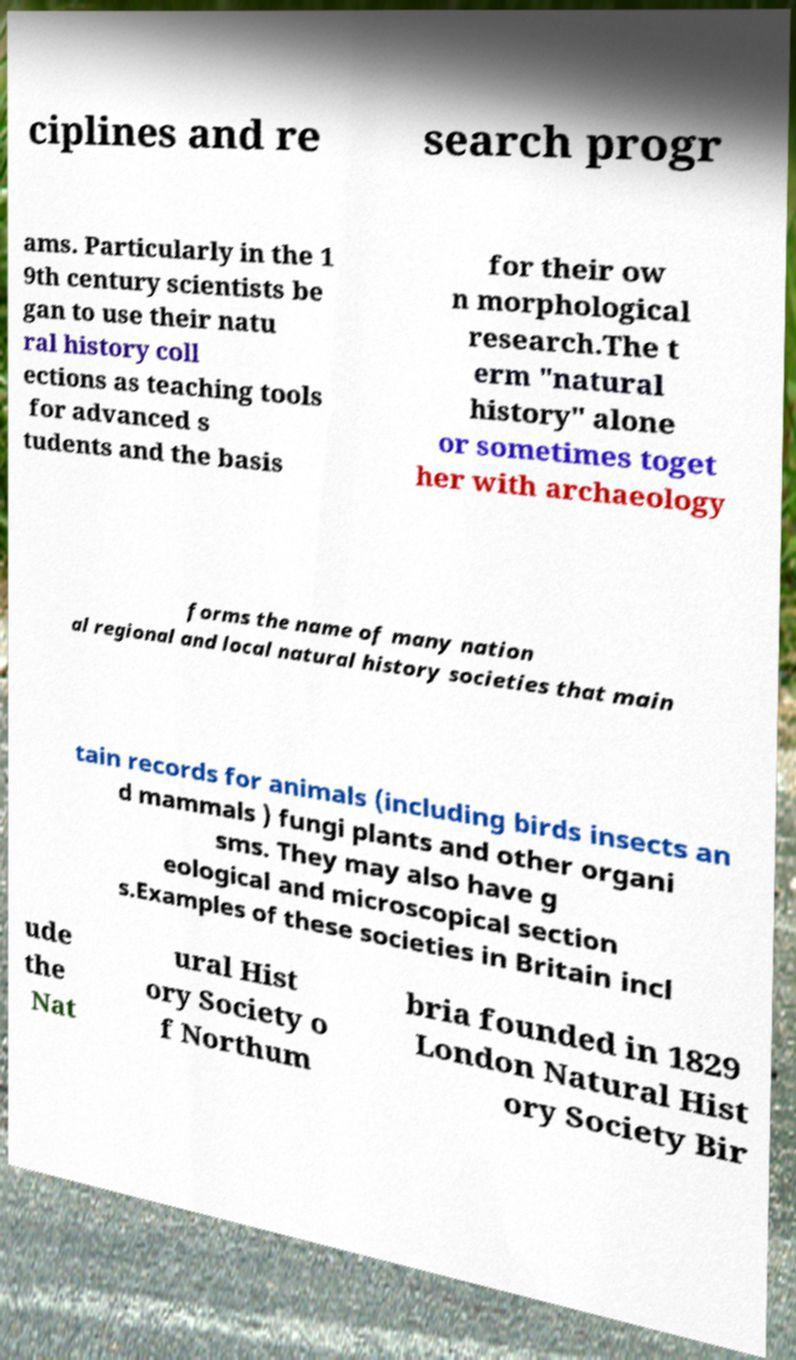For documentation purposes, I need the text within this image transcribed. Could you provide that? ciplines and re search progr ams. Particularly in the 1 9th century scientists be gan to use their natu ral history coll ections as teaching tools for advanced s tudents and the basis for their ow n morphological research.The t erm "natural history" alone or sometimes toget her with archaeology forms the name of many nation al regional and local natural history societies that main tain records for animals (including birds insects an d mammals ) fungi plants and other organi sms. They may also have g eological and microscopical section s.Examples of these societies in Britain incl ude the Nat ural Hist ory Society o f Northum bria founded in 1829 London Natural Hist ory Society Bir 